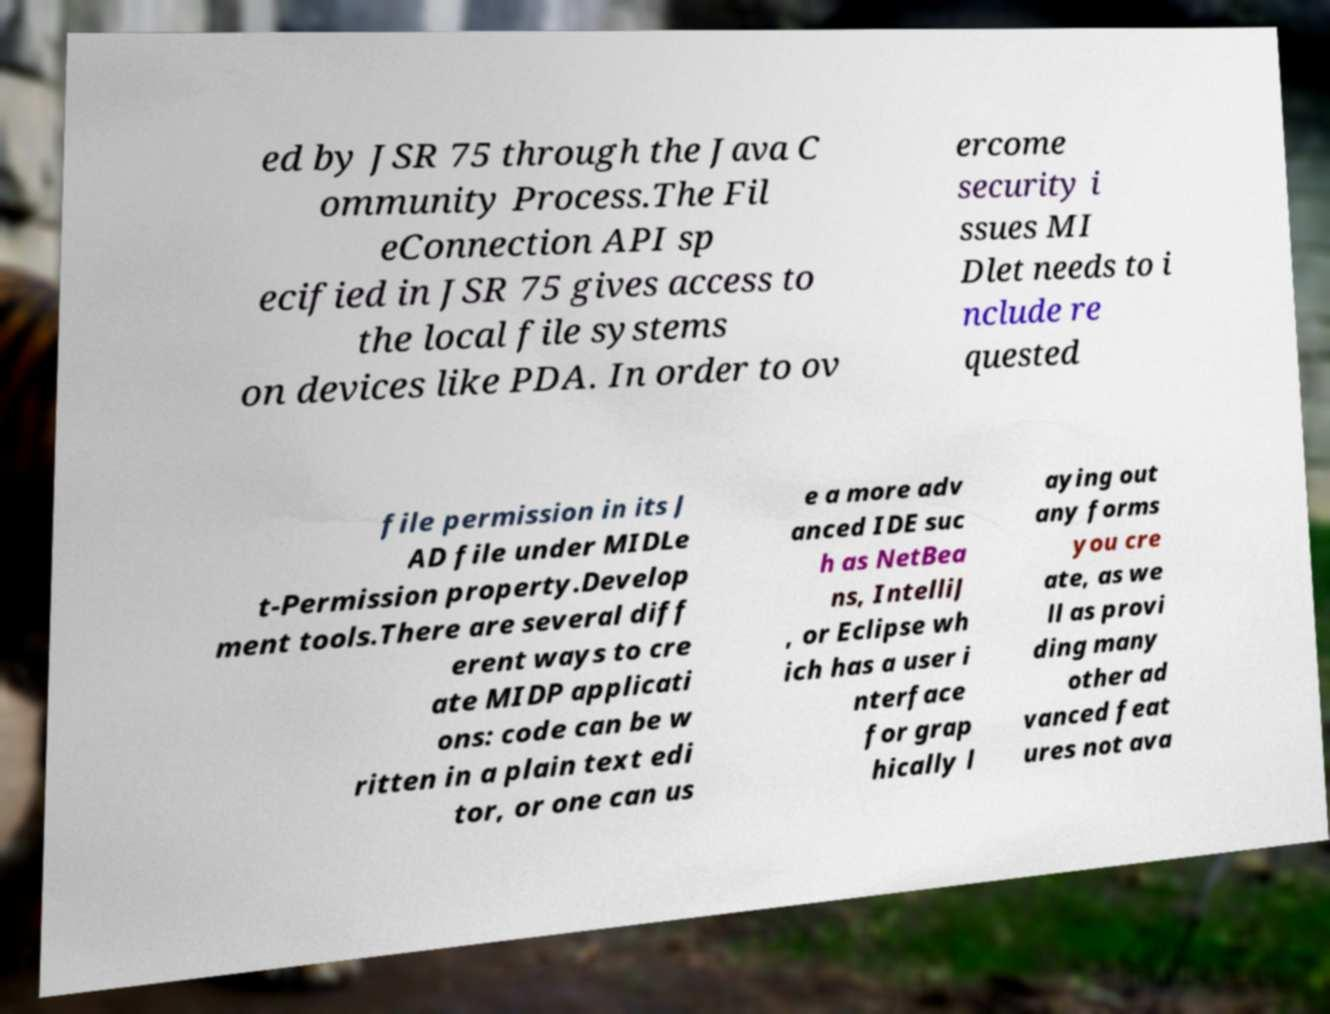Can you read and provide the text displayed in the image?This photo seems to have some interesting text. Can you extract and type it out for me? ed by JSR 75 through the Java C ommunity Process.The Fil eConnection API sp ecified in JSR 75 gives access to the local file systems on devices like PDA. In order to ov ercome security i ssues MI Dlet needs to i nclude re quested file permission in its J AD file under MIDLe t-Permission property.Develop ment tools.There are several diff erent ways to cre ate MIDP applicati ons: code can be w ritten in a plain text edi tor, or one can us e a more adv anced IDE suc h as NetBea ns, IntelliJ , or Eclipse wh ich has a user i nterface for grap hically l aying out any forms you cre ate, as we ll as provi ding many other ad vanced feat ures not ava 